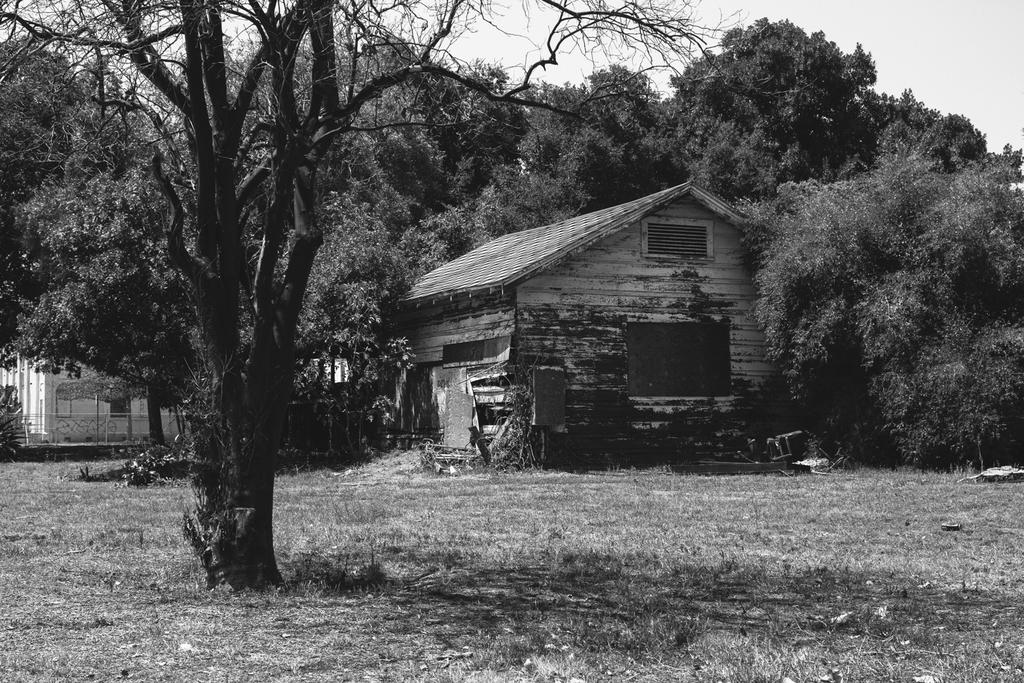What is the color scheme of the image? The image is black and white. What type of vegetation can be seen in the image? There are trees in the image. What type of structures are present in the image? There are houses in the image. What type of ground surface is visible in the image? There is grass visible in the image. What is visible in the background of the image? The sky is visible in the background of the image. What is the size of the dolls in the image? There are no dolls present in the image. How many locks can be seen securing the houses in the image? There is no mention of locks in the image; the focus is on the houses, trees, grass, and sky. 